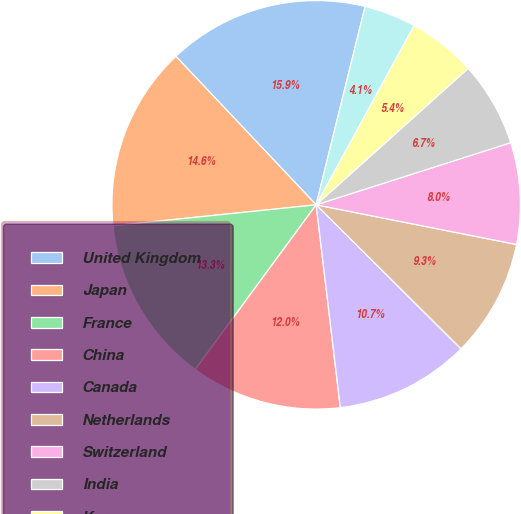Convert chart to OTSL. <chart><loc_0><loc_0><loc_500><loc_500><pie_chart><fcel>United Kingdom<fcel>Japan<fcel>France<fcel>China<fcel>Canada<fcel>Netherlands<fcel>Switzerland<fcel>India<fcel>Korea<fcel>Hong Kong<nl><fcel>15.9%<fcel>14.59%<fcel>13.28%<fcel>11.97%<fcel>10.66%<fcel>9.34%<fcel>8.03%<fcel>6.72%<fcel>5.41%<fcel>4.1%<nl></chart> 